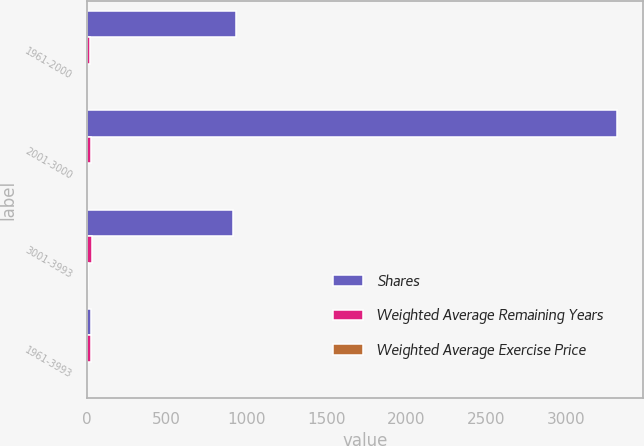Convert chart to OTSL. <chart><loc_0><loc_0><loc_500><loc_500><stacked_bar_chart><ecel><fcel>1961-2000<fcel>2001-3000<fcel>3001-3993<fcel>1961-3993<nl><fcel>Shares<fcel>936<fcel>3321<fcel>919<fcel>27.46<nl><fcel>Weighted Average Remaining Years<fcel>19.61<fcel>27.9<fcel>33.88<fcel>27.46<nl><fcel>Weighted Average Exercise Price<fcel>1.18<fcel>1.54<fcel>7.96<fcel>2.61<nl></chart> 